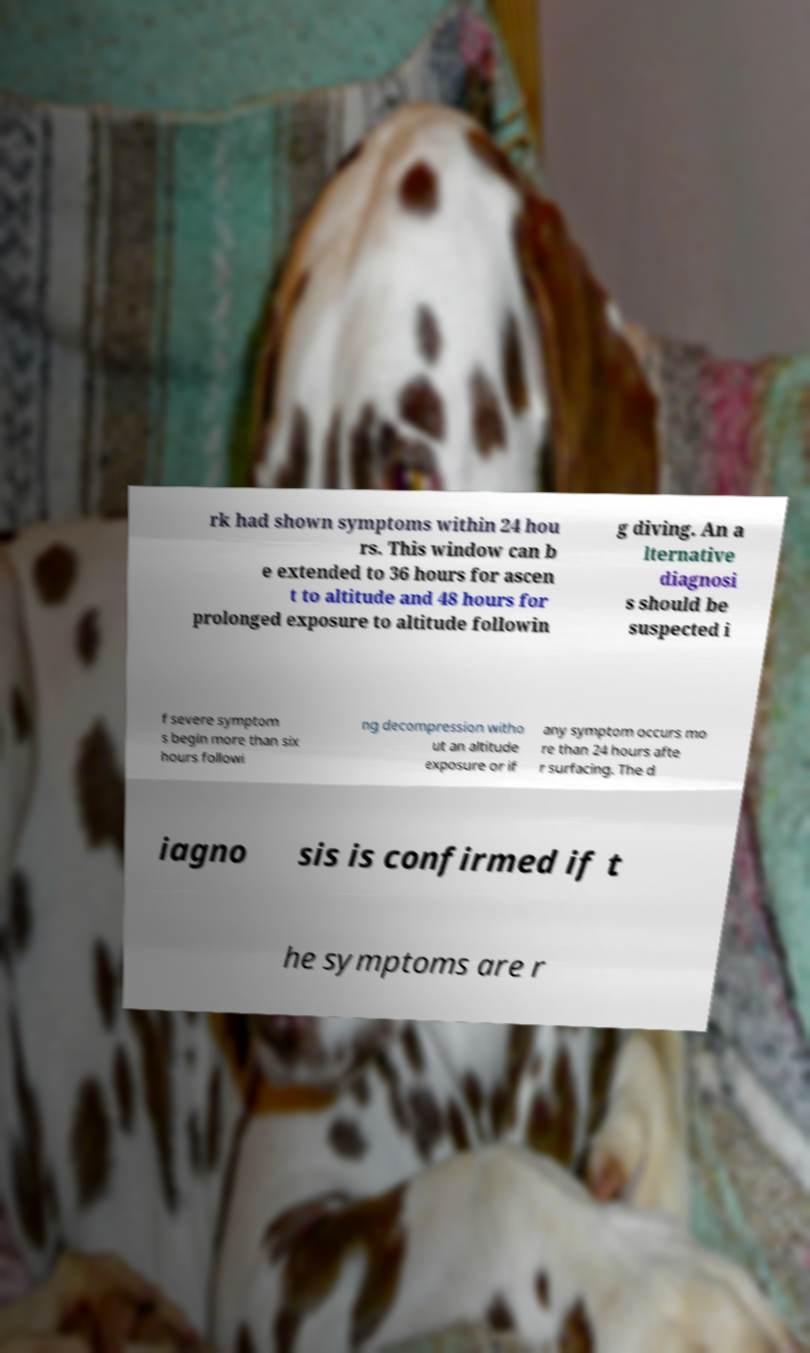Can you accurately transcribe the text from the provided image for me? rk had shown symptoms within 24 hou rs. This window can b e extended to 36 hours for ascen t to altitude and 48 hours for prolonged exposure to altitude followin g diving. An a lternative diagnosi s should be suspected i f severe symptom s begin more than six hours followi ng decompression witho ut an altitude exposure or if any symptom occurs mo re than 24 hours afte r surfacing. The d iagno sis is confirmed if t he symptoms are r 